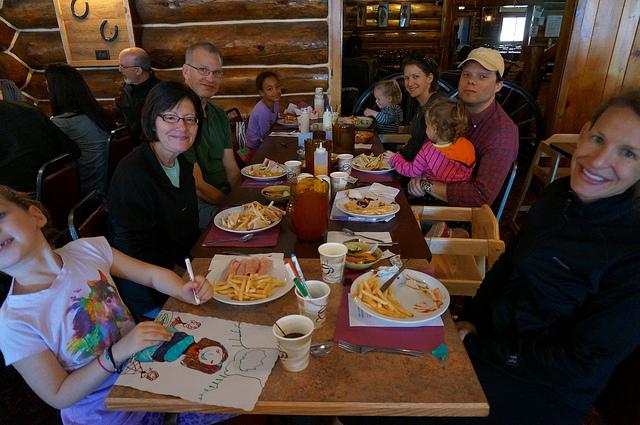Is this at a toy store?
Concise answer only. No. How old is the birthday person?
Concise answer only. 5. How many children are in the photo?
Write a very short answer. 4. Are the people waiting for their food?
Concise answer only. No. Is the woman holding a cake?
Give a very brief answer. No. How many people are in the picture?
Answer briefly. 12. The walls of this restaurant are made from what?
Quick response, please. Wood. What beverage is on the table?
Keep it brief. Coffee. What is on the shelves?
Be succinct. No shelves. How many people are at the table?
Short answer required. 9. Are they outside?
Write a very short answer. No. What article of clothing is the baby wearing to protect his shirt?
Write a very short answer. Bib. What kind of food is this?
Quick response, please. French fries. How many children are there?
Quick response, please. 4. Could these children be dressed like "Pilgrims"?
Quick response, please. No. Is the food on the table dinner food?
Write a very short answer. Yes. What type of food is on the table?
Give a very brief answer. French fries. What are the kids doing?
Give a very brief answer. Coloring. What else is on the table?
Keep it brief. Family enjoys meal out. What are they eating?
Answer briefly. Fries. What are their hats made of?
Write a very short answer. Cotton. What does this picture have in common?
Answer briefly. Food. How many plates are on the table?
Be succinct. 8. Is it Valentine's day?
Concise answer only. No. Where is the little baby?
Answer briefly. On lap. What are the people sitting on?
Give a very brief answer. Chairs. Is the child wearing pajamas?
Quick response, please. No. Have the people started eating?
Short answer required. Yes. What is the child eating?
Quick response, please. Fries. How many plates of fries are there?
Answer briefly. 6. What kind of business are the kids in?
Write a very short answer. Restaurant. What is the woman pouring?
Give a very brief answer. Nothing. Is the child on the left bored?
Be succinct. No. What color is the sippy cup?
Concise answer only. White. How many bright green chairs are shown?
Give a very brief answer. 0. What is in the bowl in front of the girl?
Give a very brief answer. Fries. What is the shape of the table?
Keep it brief. Rectangle. Is the girl in the front coloring?
Quick response, please. Yes. Is this an office party?
Concise answer only. No. Are the people eating?
Short answer required. Yes. Are these people consuming alcohol?
Keep it brief. No. How many different food groups are there?
Keep it brief. 2. What is the woman holding?
Write a very short answer. Pen. How many women are in this picture?
Give a very brief answer. 4. What are the bowls made of?
Be succinct. Glass. Is the woman wearing glasses?
Quick response, please. Yes. Are there any people present?
Be succinct. Yes. Is this a home or a public area?
Give a very brief answer. Public. How many adults are in the photo?
Write a very short answer. 7. Are any of the men looking up?
Write a very short answer. Yes. Are the people getting ready to eat the main course or dessert?
Quick response, please. Main course. What color is the man's hat?
Write a very short answer. Tan. What is on the back wall behind them?
Short answer required. Horse shoes. What are the girls sitting on?
Write a very short answer. Chairs. Might this be brunch?
Answer briefly. Yes. What is in the glass to the upper right?
Concise answer only. Soda. What culture are the dishes shown from?
Answer briefly. American. What eating utensils are being used?
Concise answer only. Fork. How many people are wearing glasses?
Give a very brief answer. 3. Is this an all American meal?
Keep it brief. Yes. What color is her sache?
Quick response, please. Black. Is this a normal restaurant?
Concise answer only. Yes. What are the people trying to do?
Answer briefly. Eat. Are the people having lunch or dinner?
Concise answer only. Lunch. Are the children enjoying the food?
Write a very short answer. Yes. What is wearing a hat?
Keep it brief. Man. How many women are sitting at the table?
Give a very brief answer. 3. What is the little girl drinking?
Be succinct. Soda. Is the table made of marble?
Quick response, please. No. 